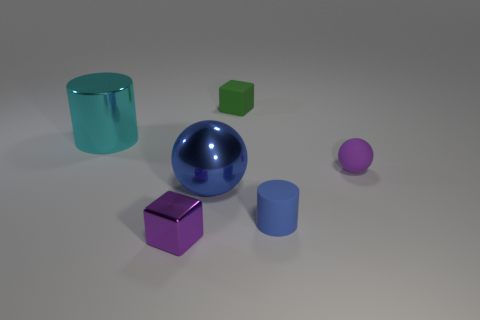Subtract all purple cylinders. Subtract all cyan cubes. How many cylinders are left? 2 Add 1 big balls. How many objects exist? 7 Subtract all blocks. How many objects are left? 4 Subtract 1 blue cylinders. How many objects are left? 5 Subtract all blue objects. Subtract all green rubber cubes. How many objects are left? 3 Add 3 small purple spheres. How many small purple spheres are left? 4 Add 5 yellow rubber cylinders. How many yellow rubber cylinders exist? 5 